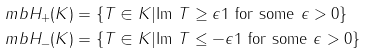Convert formula to latex. <formula><loc_0><loc_0><loc_500><loc_500>\ m b H _ { + } ( K ) & = \{ T \in K | \text {Im } T \geq \epsilon 1 \text { for some } \epsilon > 0 \} \\ \ m b H _ { - } ( K ) & = \{ T \in K | \text {Im } T \leq - \epsilon 1 \text { for some } \epsilon > 0 \}</formula> 